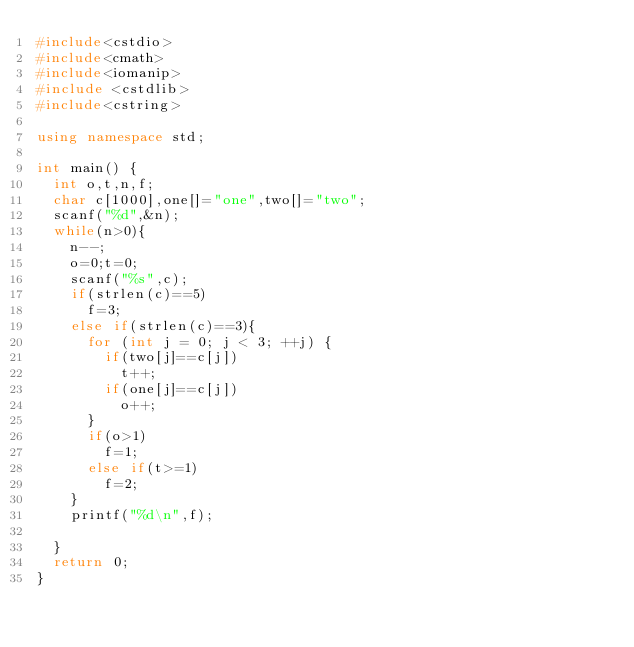<code> <loc_0><loc_0><loc_500><loc_500><_C++_>#include<cstdio>
#include<cmath>
#include<iomanip>
#include <cstdlib>
#include<cstring>

using namespace std;

int main() {
	int o,t,n,f;
	char c[1000],one[]="one",two[]="two";
	scanf("%d",&n);
	while(n>0){
		n--;
		o=0;t=0;
		scanf("%s",c);
		if(strlen(c)==5)
			f=3;
		else if(strlen(c)==3){
			for (int j = 0; j < 3; ++j) {
				if(two[j]==c[j])
					t++;
				if(one[j]==c[j])
					o++;
			}
			if(o>1)
				f=1;
			else if(t>=1)
				f=2;
		}
		printf("%d\n",f);

	}
	return 0;
}
</code> 